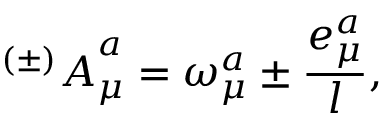Convert formula to latex. <formula><loc_0><loc_0><loc_500><loc_500>{ ^ { ( \pm ) } A } _ { \mu } ^ { a } = \omega _ { \mu } ^ { a } \pm { \frac { e _ { \mu } ^ { a } } { l } } ,</formula> 